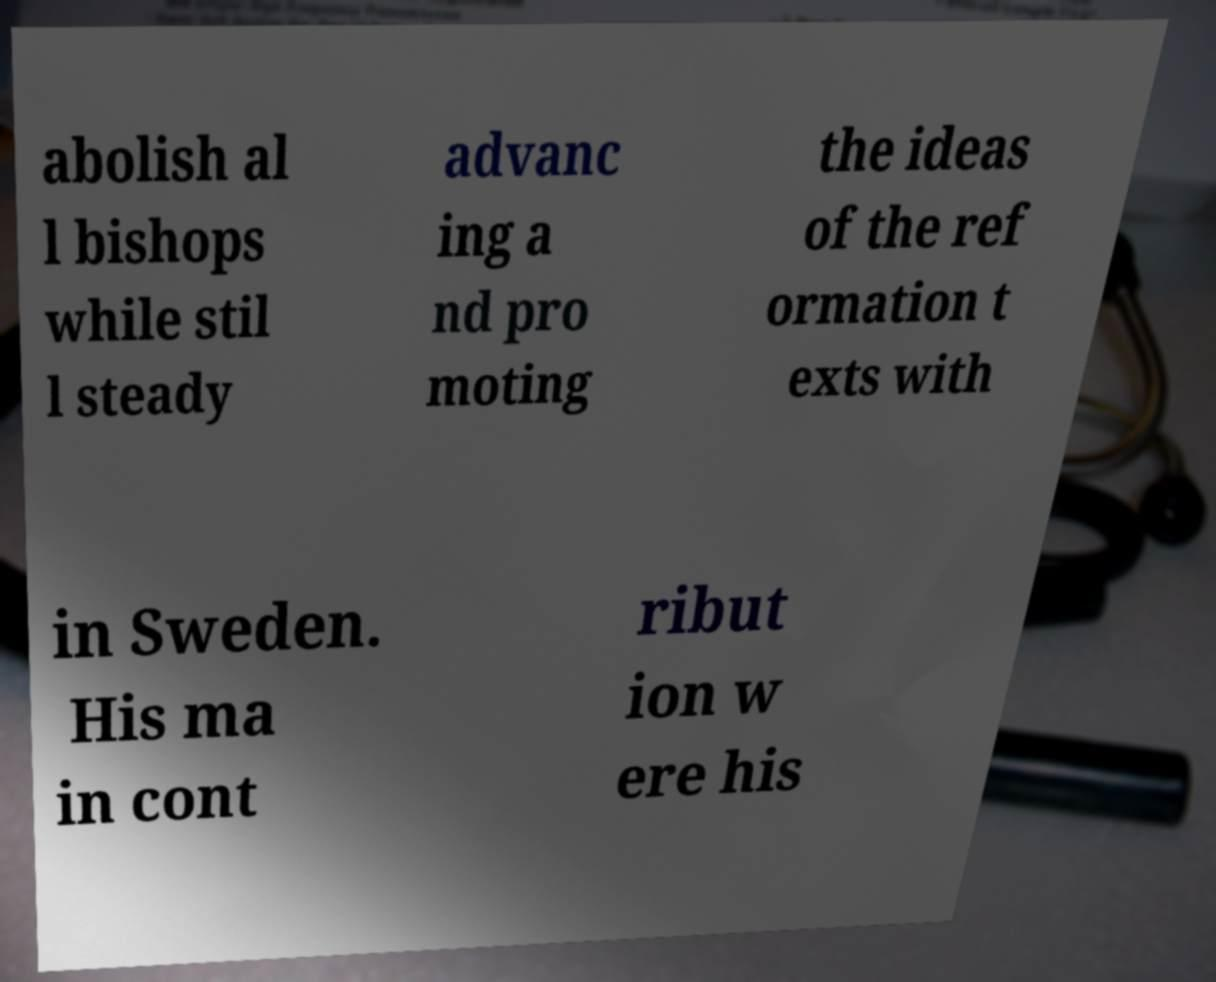Could you extract and type out the text from this image? abolish al l bishops while stil l steady advanc ing a nd pro moting the ideas of the ref ormation t exts with in Sweden. His ma in cont ribut ion w ere his 